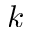Convert formula to latex. <formula><loc_0><loc_0><loc_500><loc_500>k</formula> 